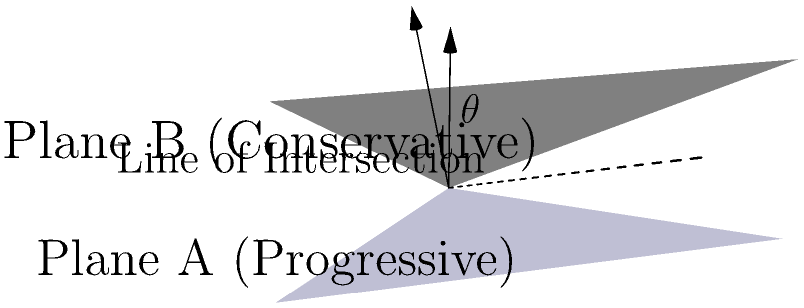In the early 20th century, progressive and conservative ideologies often clashed on issues of religious freedom and social reform. If we represent these conflicting ideologies as intersecting planes in 3D space, with the normal vector of the progressive ideology plane being $(0,0,1)$ and the normal vector of the conservative ideology plane being $(-\frac{1}{\sqrt{3}},-\frac{1}{\sqrt{3}},\frac{1}{\sqrt{3}})$, what is the angle $\theta$ between these two planes? To find the angle between two planes, we can use the angle between their normal vectors. The formula for the angle between two vectors $\mathbf{a}$ and $\mathbf{b}$ is:

$$\cos \theta = \frac{\mathbf{a} \cdot \mathbf{b}}{|\mathbf{a}||\mathbf{b}|}$$

Step 1: Identify the normal vectors:
$\mathbf{a} = (0,0,1)$ for the progressive ideology plane
$\mathbf{b} = (-\frac{1}{\sqrt{3}},-\frac{1}{\sqrt{3}},\frac{1}{\sqrt{3}})$ for the conservative ideology plane

Step 2: Calculate the dot product $\mathbf{a} \cdot \mathbf{b}$:
$$\mathbf{a} \cdot \mathbf{b} = (0)(- \frac{1}{\sqrt{3}}) + (0)(- \frac{1}{\sqrt{3}}) + (1)( \frac{1}{\sqrt{3}}) = \frac{1}{\sqrt{3}}$$

Step 3: Calculate the magnitudes of the vectors:
$|\mathbf{a}| = \sqrt{0^2 + 0^2 + 1^2} = 1$
$|\mathbf{b}| = \sqrt{(\frac{1}{\sqrt{3}})^2 + (\frac{1}{\sqrt{3}})^2 + (\frac{1}{\sqrt{3}})^2} = 1$

Step 4: Apply the formula:
$$\cos \theta = \frac{\frac{1}{\sqrt{3}}}{(1)(1)} = \frac{1}{\sqrt{3}}$$

Step 5: Solve for $\theta$:
$$\theta = \arccos(\frac{1}{\sqrt{3}}) \approx 54.74^\circ$$

This angle represents the ideological gap between progressive and conservative views on religious and social issues in early 20th century America.
Answer: $54.74^\circ$ 